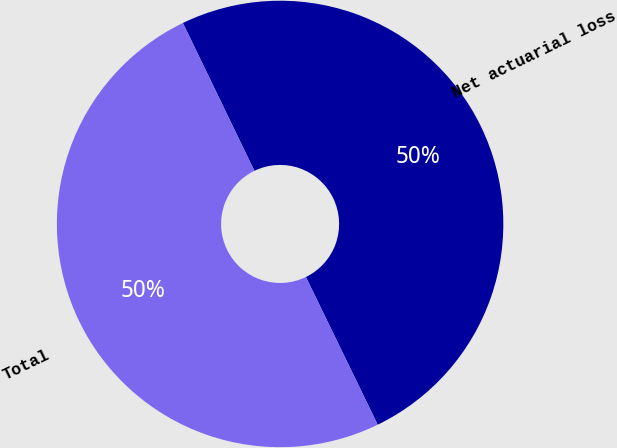Convert chart. <chart><loc_0><loc_0><loc_500><loc_500><pie_chart><fcel>Net actuarial loss<fcel>Total<nl><fcel>49.97%<fcel>50.03%<nl></chart> 